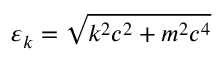Convert formula to latex. <formula><loc_0><loc_0><loc_500><loc_500>\varepsilon _ { k } = \sqrt { k ^ { 2 } c ^ { 2 } + m ^ { 2 } c ^ { 4 } }</formula> 